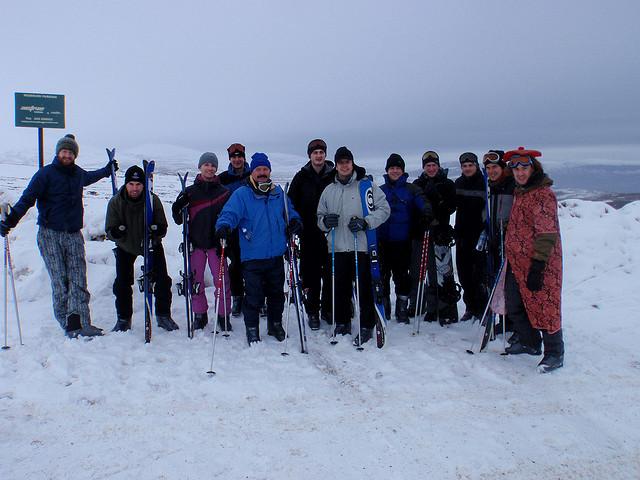Are they related?
Short answer required. Yes. How many people are posing?
Keep it brief. 12. Are these people part of a team?
Answer briefly. Yes. How many people are in the photo?
Write a very short answer. 12. Is it foggy?
Concise answer only. No. What are the people standing on?
Concise answer only. Snow. Is there snow?
Answer briefly. Yes. Is this a ski tournament?
Quick response, please. No. What sport are these people participating in?
Short answer required. Skiing. Is the photo colored?
Short answer required. Yes. What are these people standing on?
Be succinct. Snow. How many people are smiling?
Give a very brief answer. 12. What are these people about to do?
Quick response, please. Ski. Does everyone have a ski board?
Quick response, please. No. How many people are standing for photograph?
Keep it brief. 12. What is in the background of the photo?
Give a very brief answer. Clouds. 